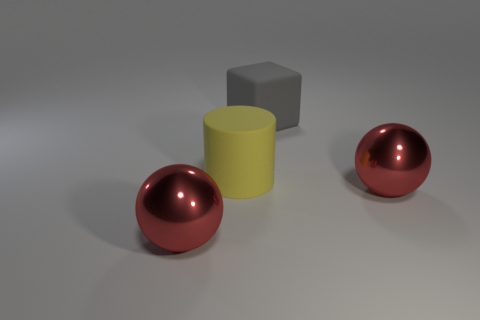What is the big gray block made of?
Provide a short and direct response. Rubber. What shape is the big red object on the right side of the gray matte cube that is behind the red ball to the left of the gray rubber cube?
Keep it short and to the point. Sphere. How many other objects are the same shape as the big gray thing?
Provide a succinct answer. 0. There is a large cylinder; does it have the same color as the big metal thing on the left side of the large gray rubber object?
Offer a very short reply. No. How many big red metallic things are there?
Ensure brevity in your answer.  2. What number of objects are either small metal objects or large shiny balls?
Your response must be concise. 2. Are there any cubes to the left of the big cube?
Ensure brevity in your answer.  No. Are there more yellow things left of the big cylinder than yellow things that are behind the gray rubber object?
Offer a terse response. No. What number of cylinders are large gray shiny objects or red objects?
Your answer should be compact. 0. Are there fewer large metallic things on the left side of the large gray matte block than balls in front of the yellow matte cylinder?
Give a very brief answer. Yes. 